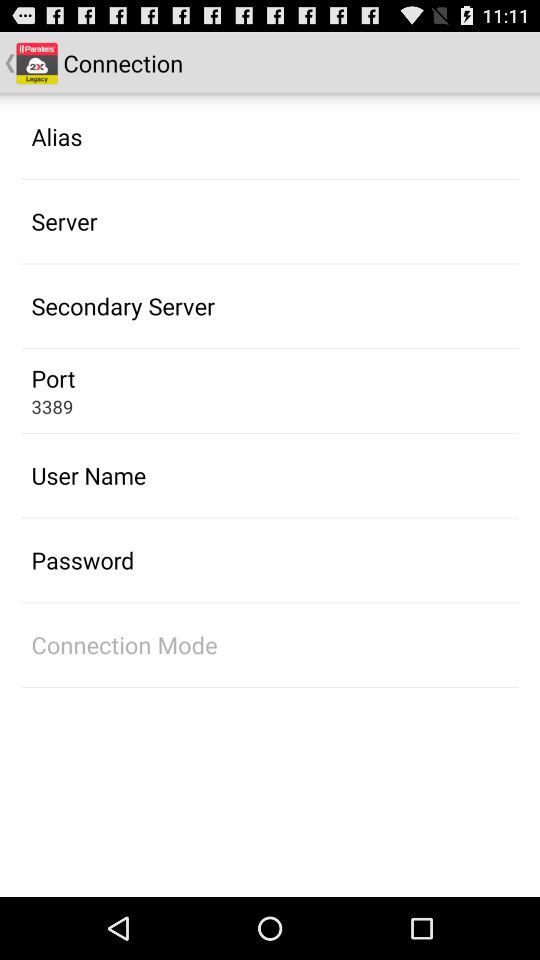How many items have a text value of '3389'?
Answer the question using a single word or phrase. 1 